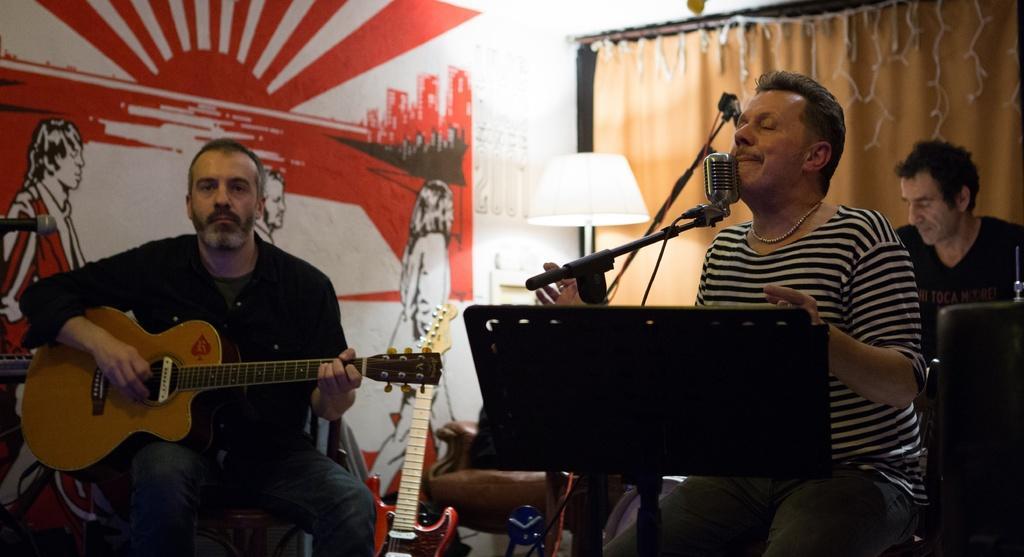Describe this image in one or two sentences. In this image, There are some people sitting on the chairs and they are holding some music instruments and there is a microphone which is in black color, There is a man singing in the microphone, In the background there is a wall in yellow color. 